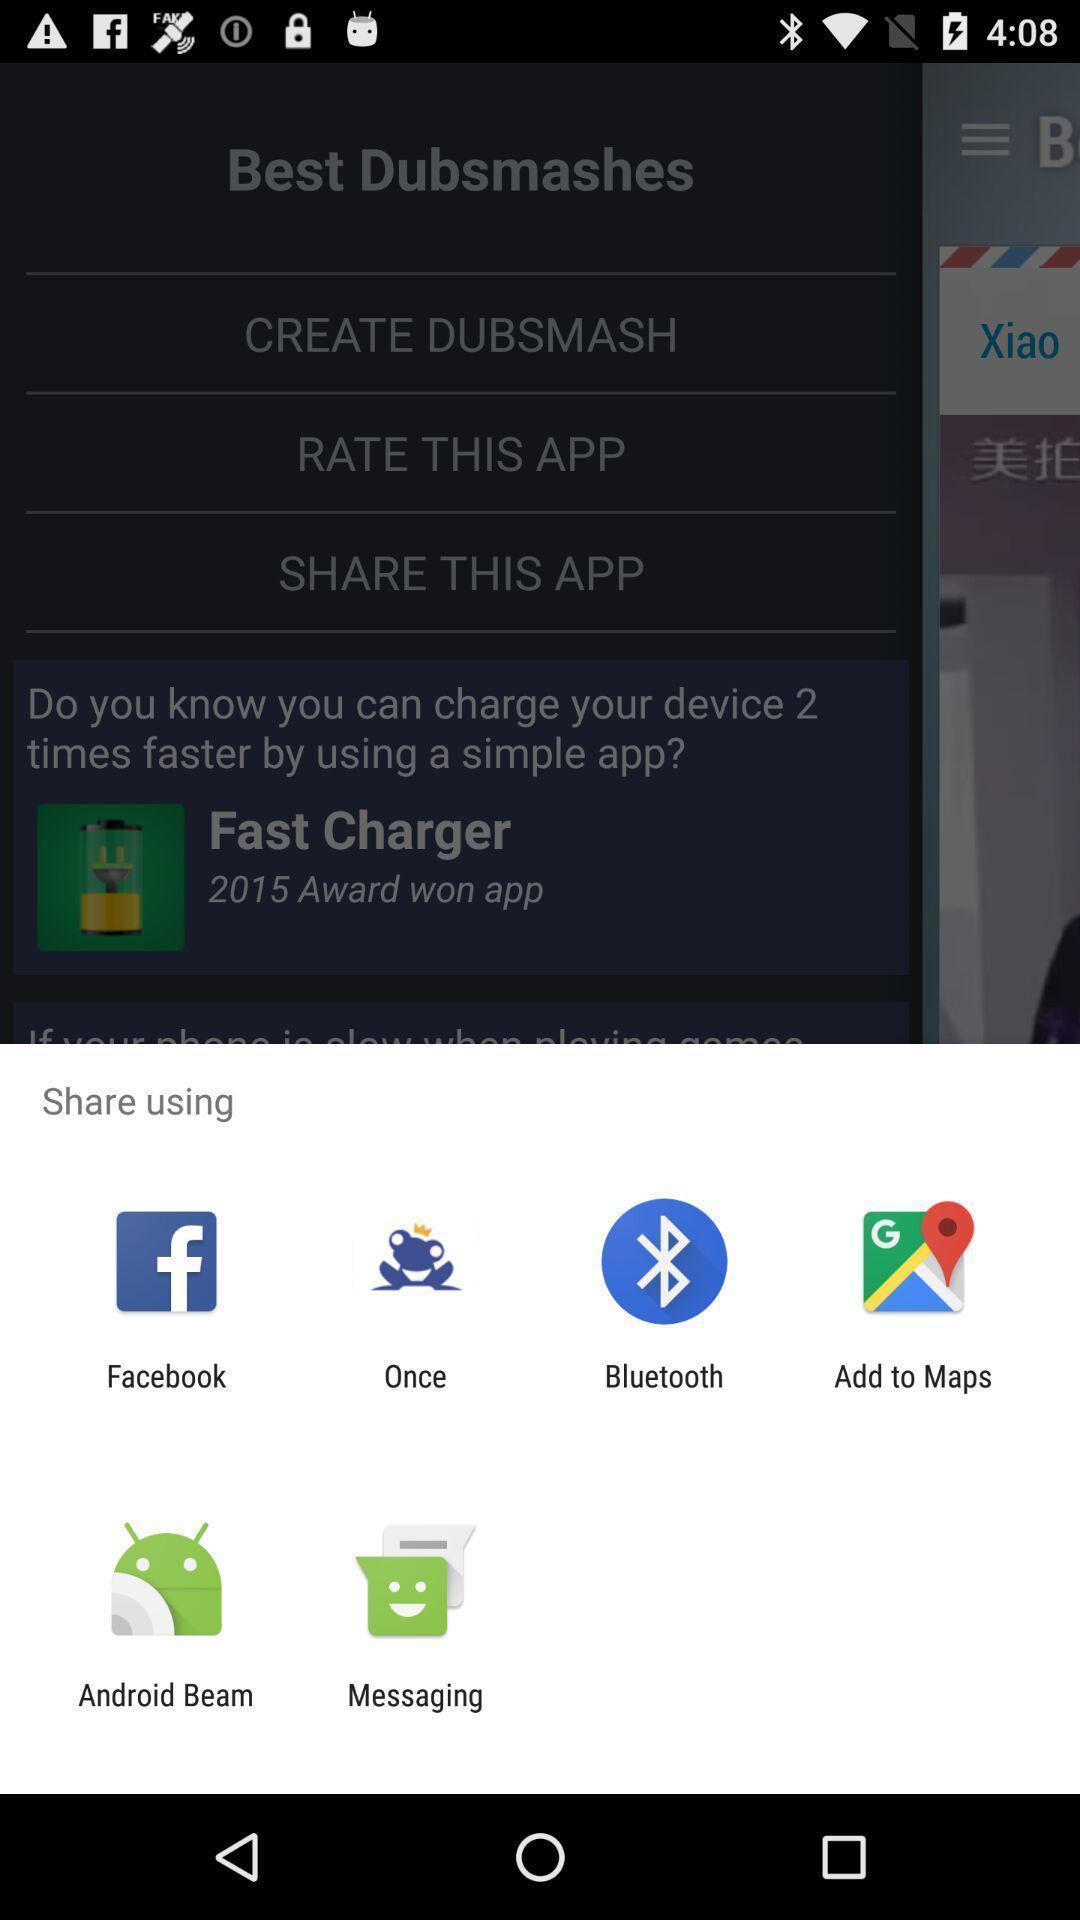Describe the visual elements of this screenshot. Pop-up showing different sharing options. 